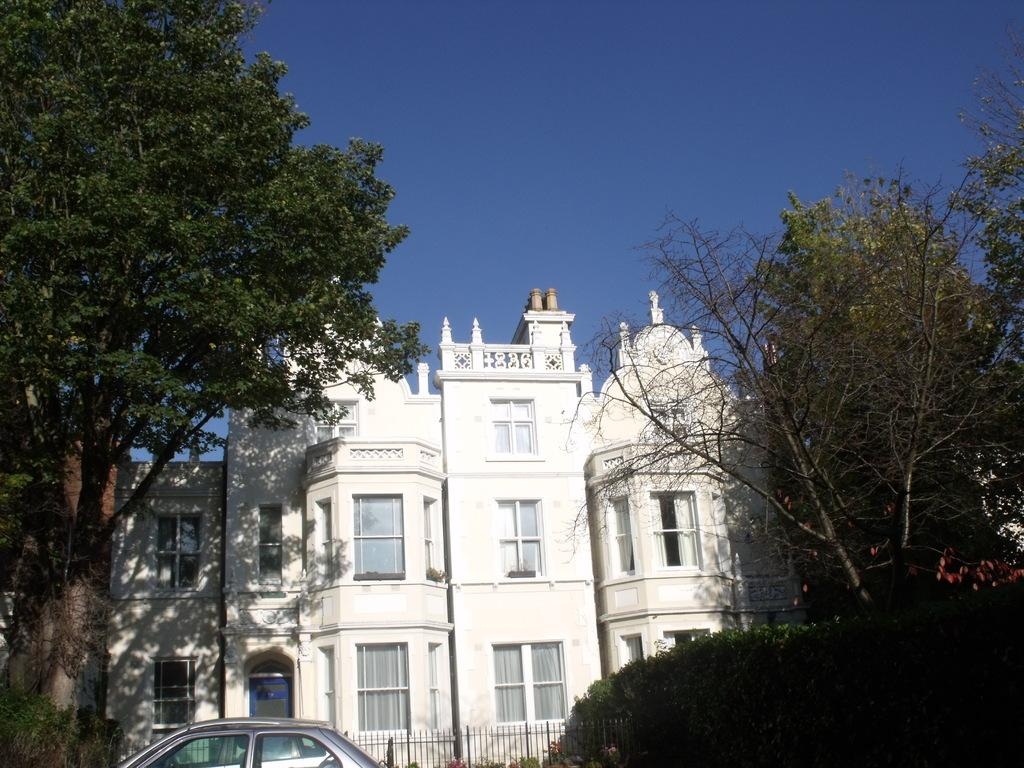What type of structures can be seen in the image? There are buildings in the image. What feature can be observed on the buildings? There are windows visible on the buildings. What type of vegetation is present in the image? There are trees in the image. What type of barrier is present in the image? There is a fence in the image. What is parked in front of the building? There is a vehicle in front of the building. What can be seen in the background of the image? The sky is visible in the background of the image. How many receipts are visible in the image? There are no receipts present in the image. What type of bikes can be seen in the image? There are no bikes present in the image. 